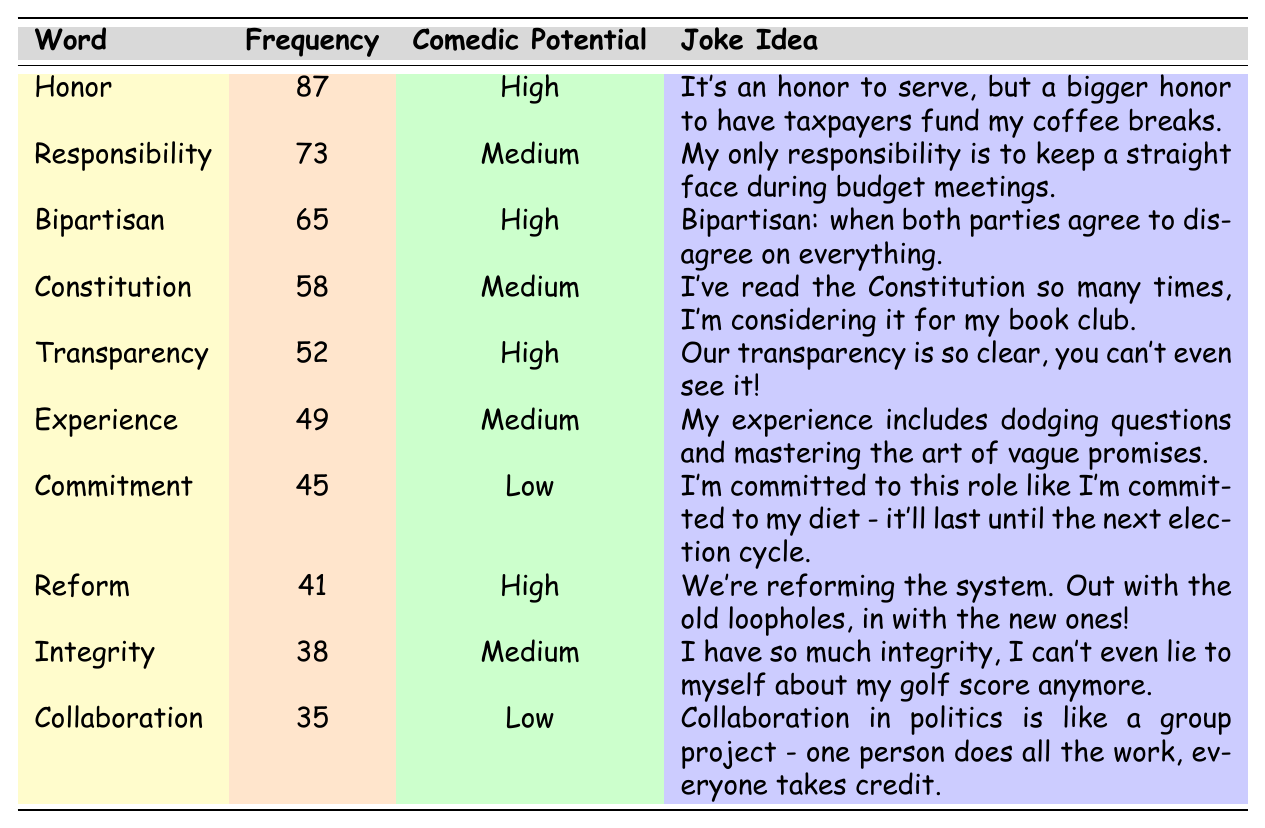What is the most frequently used word in the speeches? The table shows that the word "Honor" has the highest frequency with 87 occurrences.
Answer: Honor Which word has the lowest comedic potential? Looking at the comedic potential ratings, "Commitment" has the lowest potential categorized as "Low."
Answer: Commitment How many words in the table have a high comedic potential? The words "Honor," "Bipartisan," "Transparency," "Reform" have high comedic potential. There are 4 such words in total.
Answer: 4 What is the frequency of the word "Reform"? The table indicates that "Reform" appears 41 times in the speeches.
Answer: 41 Is "Integrity" mentioned more frequently than "Commitment"? Comparing the frequencies, "Integrity" (38) is mentioned less frequently than "Commitment" (45). So, the answer is no.
Answer: No What is the average frequency of the words with medium comedic potential? The frequencies for words with medium comedic potential are 73 (Responsibility), 58 (Constitution), 49 (Experience), and 38 (Integrity). The average is calculated by summing these numbers (73 + 58 + 49 + 38 = 218) and dividing by 4, resulting in an average of 54.5.
Answer: 54.5 Which word with high comedic potential has the funniest joke idea according to the table? All high comedic potential words, namely "Honor," "Bipartisan," "Transparency," and "Reform," have amusing joke ideas. Among them, "Bipartisan" relates humorously to political disagreements, making it particularly funny.
Answer: Bipartisan How many more times is the word "Honor" used compared to "Collaboration"? The frequency for "Honor" is 87, and for "Collaboration," it is 35. The difference is 87 - 35 = 52, meaning "Honor" is used 52 more times.
Answer: 52 What do the majority of the jokes point towards in terms of political culture? The jokes highlight a humorous critique of political accountability, vague promises, and the challenges of collaboration, suggesting a satirical view of political culture.
Answer: Satirical critique of political culture 